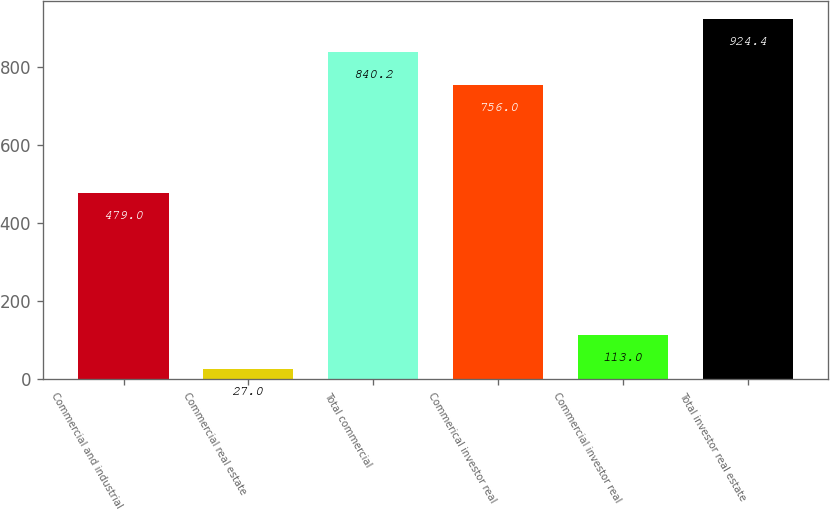<chart> <loc_0><loc_0><loc_500><loc_500><bar_chart><fcel>Commercial and industrial<fcel>Commercial real estate<fcel>Total commercial<fcel>Commerical investor real<fcel>Commercial investor real<fcel>Total investor real estate<nl><fcel>479<fcel>27<fcel>840.2<fcel>756<fcel>113<fcel>924.4<nl></chart> 